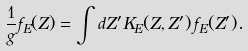<formula> <loc_0><loc_0><loc_500><loc_500>\frac { 1 } { g } f _ { E } ( Z ) = \int d Z ^ { \prime } K _ { E } ( Z , Z ^ { \prime } ) \, f _ { E } ( Z ^ { \prime } ) .</formula> 